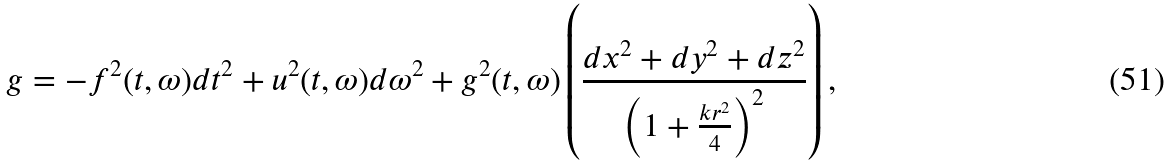<formula> <loc_0><loc_0><loc_500><loc_500>g = - f ^ { 2 } ( t , \omega ) d t ^ { 2 } + u ^ { 2 } ( t , \omega ) d \omega ^ { 2 } + g ^ { 2 } ( t , \omega ) \left ( \frac { d x ^ { 2 } + d y ^ { 2 } + d z ^ { 2 } } { \left ( 1 + \frac { k r ^ { 2 } } { 4 } \right ) ^ { 2 } } \right ) ,</formula> 